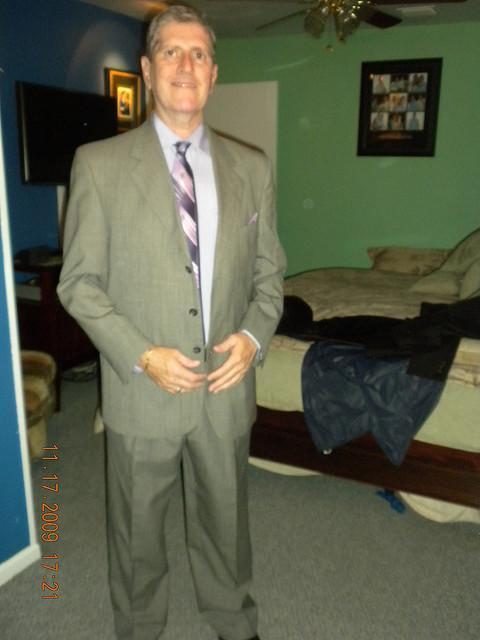How many hot dog buns are in the picture?
Give a very brief answer. 0. 